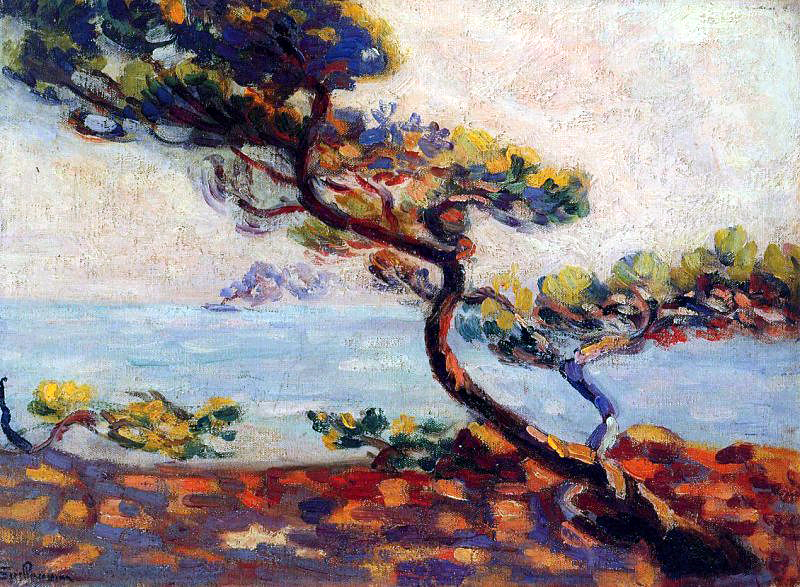If you could add another element to this painting, what would it be and why? If I were to add another element to this painting, I would include a small sailboat in the distant waters. This addition would create a focal point that draws the viewer's eye across the composition, adding a narrative element and enhancing the sense of space and depth in the scene. The sailboat could also symbolize human presence and adventure, contrasting with the tranquility and permanence of the natural elements. 